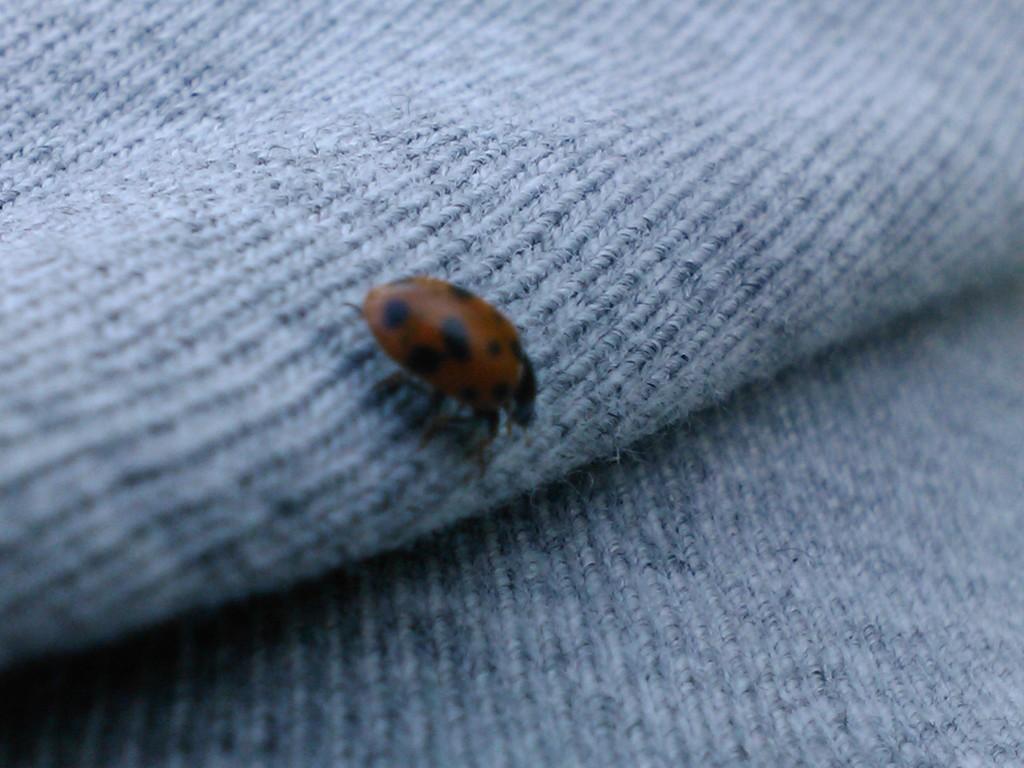Please provide a concise description of this image. In this image we can see an insect. In the background of the image there is an object. 